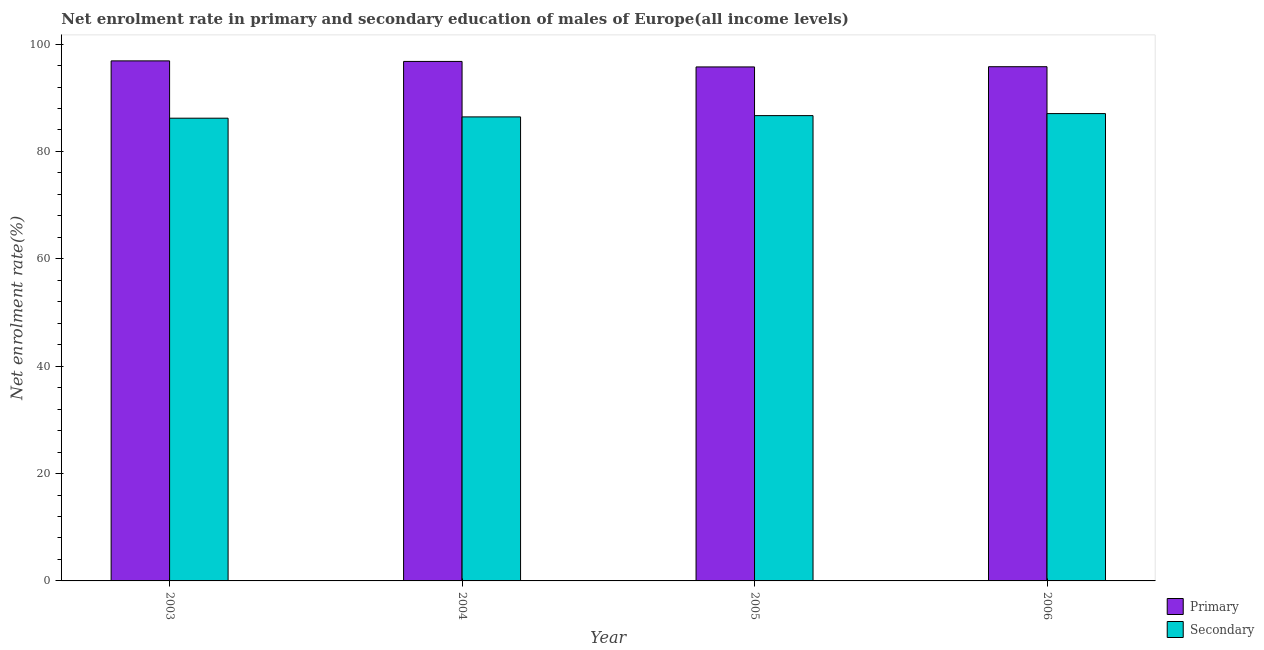How many different coloured bars are there?
Keep it short and to the point. 2. How many groups of bars are there?
Your response must be concise. 4. Are the number of bars on each tick of the X-axis equal?
Provide a succinct answer. Yes. In how many cases, is the number of bars for a given year not equal to the number of legend labels?
Give a very brief answer. 0. What is the enrollment rate in primary education in 2003?
Provide a short and direct response. 96.87. Across all years, what is the maximum enrollment rate in secondary education?
Provide a short and direct response. 87.05. Across all years, what is the minimum enrollment rate in secondary education?
Ensure brevity in your answer.  86.19. In which year was the enrollment rate in primary education maximum?
Keep it short and to the point. 2003. What is the total enrollment rate in secondary education in the graph?
Make the answer very short. 346.34. What is the difference between the enrollment rate in secondary education in 2004 and that in 2006?
Keep it short and to the point. -0.62. What is the difference between the enrollment rate in secondary education in 2003 and the enrollment rate in primary education in 2004?
Provide a short and direct response. -0.24. What is the average enrollment rate in secondary education per year?
Ensure brevity in your answer.  86.59. In the year 2006, what is the difference between the enrollment rate in primary education and enrollment rate in secondary education?
Offer a very short reply. 0. What is the ratio of the enrollment rate in secondary education in 2003 to that in 2005?
Offer a very short reply. 0.99. Is the difference between the enrollment rate in secondary education in 2003 and 2005 greater than the difference between the enrollment rate in primary education in 2003 and 2005?
Offer a very short reply. No. What is the difference between the highest and the second highest enrollment rate in secondary education?
Offer a very short reply. 0.38. What is the difference between the highest and the lowest enrollment rate in secondary education?
Your answer should be compact. 0.86. Is the sum of the enrollment rate in primary education in 2005 and 2006 greater than the maximum enrollment rate in secondary education across all years?
Provide a succinct answer. Yes. What does the 1st bar from the left in 2004 represents?
Provide a short and direct response. Primary. What does the 1st bar from the right in 2005 represents?
Offer a very short reply. Secondary. How many bars are there?
Your answer should be compact. 8. Are all the bars in the graph horizontal?
Give a very brief answer. No. Are the values on the major ticks of Y-axis written in scientific E-notation?
Keep it short and to the point. No. Does the graph contain any zero values?
Offer a very short reply. No. How many legend labels are there?
Your response must be concise. 2. What is the title of the graph?
Ensure brevity in your answer.  Net enrolment rate in primary and secondary education of males of Europe(all income levels). What is the label or title of the Y-axis?
Offer a very short reply. Net enrolment rate(%). What is the Net enrolment rate(%) in Primary in 2003?
Keep it short and to the point. 96.87. What is the Net enrolment rate(%) of Secondary in 2003?
Ensure brevity in your answer.  86.19. What is the Net enrolment rate(%) of Primary in 2004?
Keep it short and to the point. 96.76. What is the Net enrolment rate(%) in Secondary in 2004?
Provide a short and direct response. 86.43. What is the Net enrolment rate(%) of Primary in 2005?
Your answer should be very brief. 95.74. What is the Net enrolment rate(%) of Secondary in 2005?
Your answer should be compact. 86.67. What is the Net enrolment rate(%) of Primary in 2006?
Provide a succinct answer. 95.78. What is the Net enrolment rate(%) in Secondary in 2006?
Offer a very short reply. 87.05. Across all years, what is the maximum Net enrolment rate(%) in Primary?
Your response must be concise. 96.87. Across all years, what is the maximum Net enrolment rate(%) of Secondary?
Keep it short and to the point. 87.05. Across all years, what is the minimum Net enrolment rate(%) in Primary?
Ensure brevity in your answer.  95.74. Across all years, what is the minimum Net enrolment rate(%) of Secondary?
Offer a very short reply. 86.19. What is the total Net enrolment rate(%) of Primary in the graph?
Offer a very short reply. 385.15. What is the total Net enrolment rate(%) in Secondary in the graph?
Offer a very short reply. 346.34. What is the difference between the Net enrolment rate(%) of Primary in 2003 and that in 2004?
Make the answer very short. 0.1. What is the difference between the Net enrolment rate(%) in Secondary in 2003 and that in 2004?
Make the answer very short. -0.24. What is the difference between the Net enrolment rate(%) in Primary in 2003 and that in 2005?
Your answer should be compact. 1.13. What is the difference between the Net enrolment rate(%) of Secondary in 2003 and that in 2005?
Keep it short and to the point. -0.48. What is the difference between the Net enrolment rate(%) in Primary in 2003 and that in 2006?
Provide a succinct answer. 1.09. What is the difference between the Net enrolment rate(%) in Secondary in 2003 and that in 2006?
Offer a terse response. -0.86. What is the difference between the Net enrolment rate(%) in Secondary in 2004 and that in 2005?
Keep it short and to the point. -0.24. What is the difference between the Net enrolment rate(%) in Primary in 2004 and that in 2006?
Ensure brevity in your answer.  0.98. What is the difference between the Net enrolment rate(%) of Secondary in 2004 and that in 2006?
Your answer should be compact. -0.62. What is the difference between the Net enrolment rate(%) of Primary in 2005 and that in 2006?
Make the answer very short. -0.04. What is the difference between the Net enrolment rate(%) in Secondary in 2005 and that in 2006?
Provide a succinct answer. -0.38. What is the difference between the Net enrolment rate(%) in Primary in 2003 and the Net enrolment rate(%) in Secondary in 2004?
Offer a terse response. 10.43. What is the difference between the Net enrolment rate(%) of Primary in 2003 and the Net enrolment rate(%) of Secondary in 2005?
Your answer should be very brief. 10.2. What is the difference between the Net enrolment rate(%) of Primary in 2003 and the Net enrolment rate(%) of Secondary in 2006?
Offer a terse response. 9.82. What is the difference between the Net enrolment rate(%) in Primary in 2004 and the Net enrolment rate(%) in Secondary in 2005?
Offer a very short reply. 10.09. What is the difference between the Net enrolment rate(%) in Primary in 2004 and the Net enrolment rate(%) in Secondary in 2006?
Provide a short and direct response. 9.72. What is the difference between the Net enrolment rate(%) of Primary in 2005 and the Net enrolment rate(%) of Secondary in 2006?
Make the answer very short. 8.69. What is the average Net enrolment rate(%) in Primary per year?
Provide a succinct answer. 96.29. What is the average Net enrolment rate(%) of Secondary per year?
Make the answer very short. 86.59. In the year 2003, what is the difference between the Net enrolment rate(%) in Primary and Net enrolment rate(%) in Secondary?
Make the answer very short. 10.68. In the year 2004, what is the difference between the Net enrolment rate(%) in Primary and Net enrolment rate(%) in Secondary?
Provide a short and direct response. 10.33. In the year 2005, what is the difference between the Net enrolment rate(%) in Primary and Net enrolment rate(%) in Secondary?
Your answer should be compact. 9.07. In the year 2006, what is the difference between the Net enrolment rate(%) in Primary and Net enrolment rate(%) in Secondary?
Provide a succinct answer. 8.73. What is the ratio of the Net enrolment rate(%) in Primary in 2003 to that in 2005?
Ensure brevity in your answer.  1.01. What is the ratio of the Net enrolment rate(%) of Secondary in 2003 to that in 2005?
Give a very brief answer. 0.99. What is the ratio of the Net enrolment rate(%) in Primary in 2003 to that in 2006?
Your answer should be very brief. 1.01. What is the ratio of the Net enrolment rate(%) in Secondary in 2003 to that in 2006?
Ensure brevity in your answer.  0.99. What is the ratio of the Net enrolment rate(%) of Primary in 2004 to that in 2005?
Offer a terse response. 1.01. What is the ratio of the Net enrolment rate(%) of Primary in 2004 to that in 2006?
Provide a succinct answer. 1.01. What is the ratio of the Net enrolment rate(%) of Secondary in 2004 to that in 2006?
Your answer should be very brief. 0.99. What is the ratio of the Net enrolment rate(%) of Secondary in 2005 to that in 2006?
Provide a short and direct response. 1. What is the difference between the highest and the second highest Net enrolment rate(%) in Primary?
Your answer should be very brief. 0.1. What is the difference between the highest and the second highest Net enrolment rate(%) in Secondary?
Provide a succinct answer. 0.38. What is the difference between the highest and the lowest Net enrolment rate(%) in Primary?
Offer a very short reply. 1.13. 